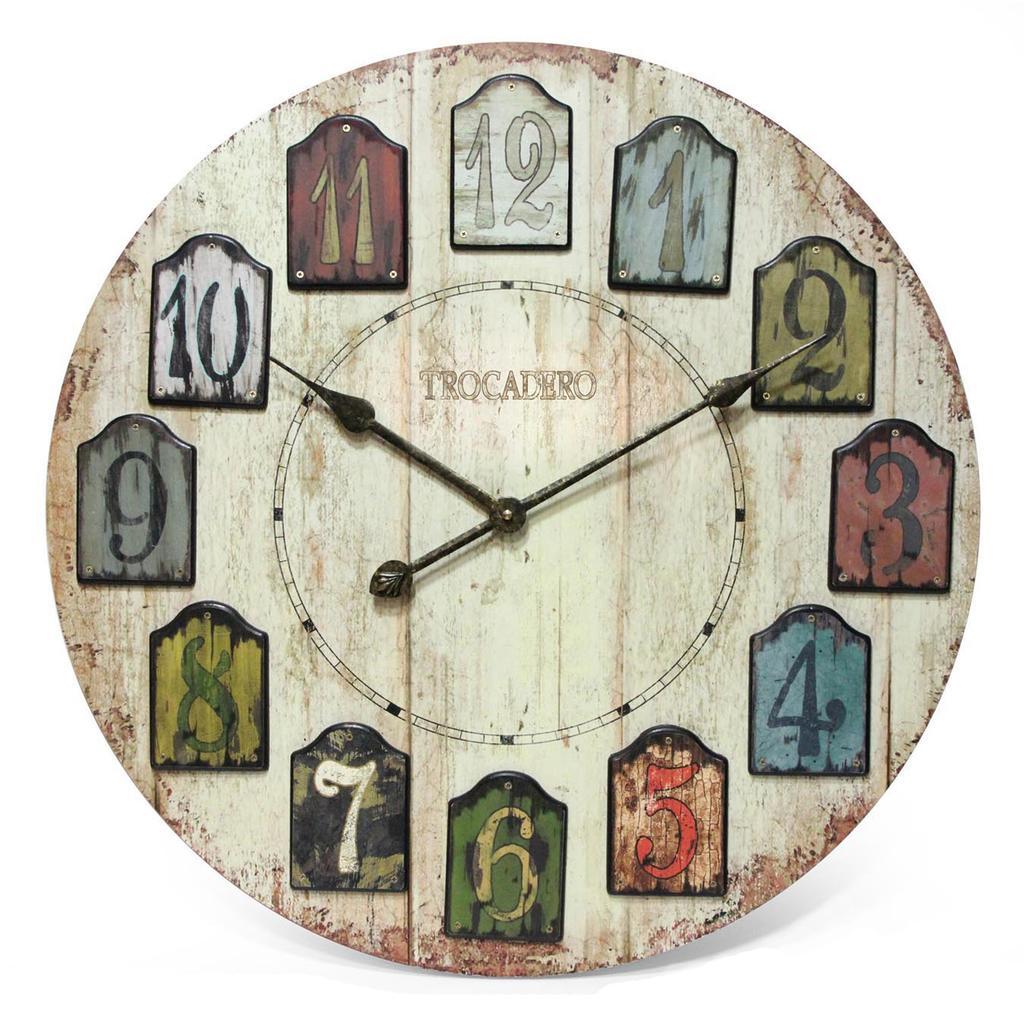<image>
Offer a succinct explanation of the picture presented. A clock by the company Trocadero is set to 10:10. 